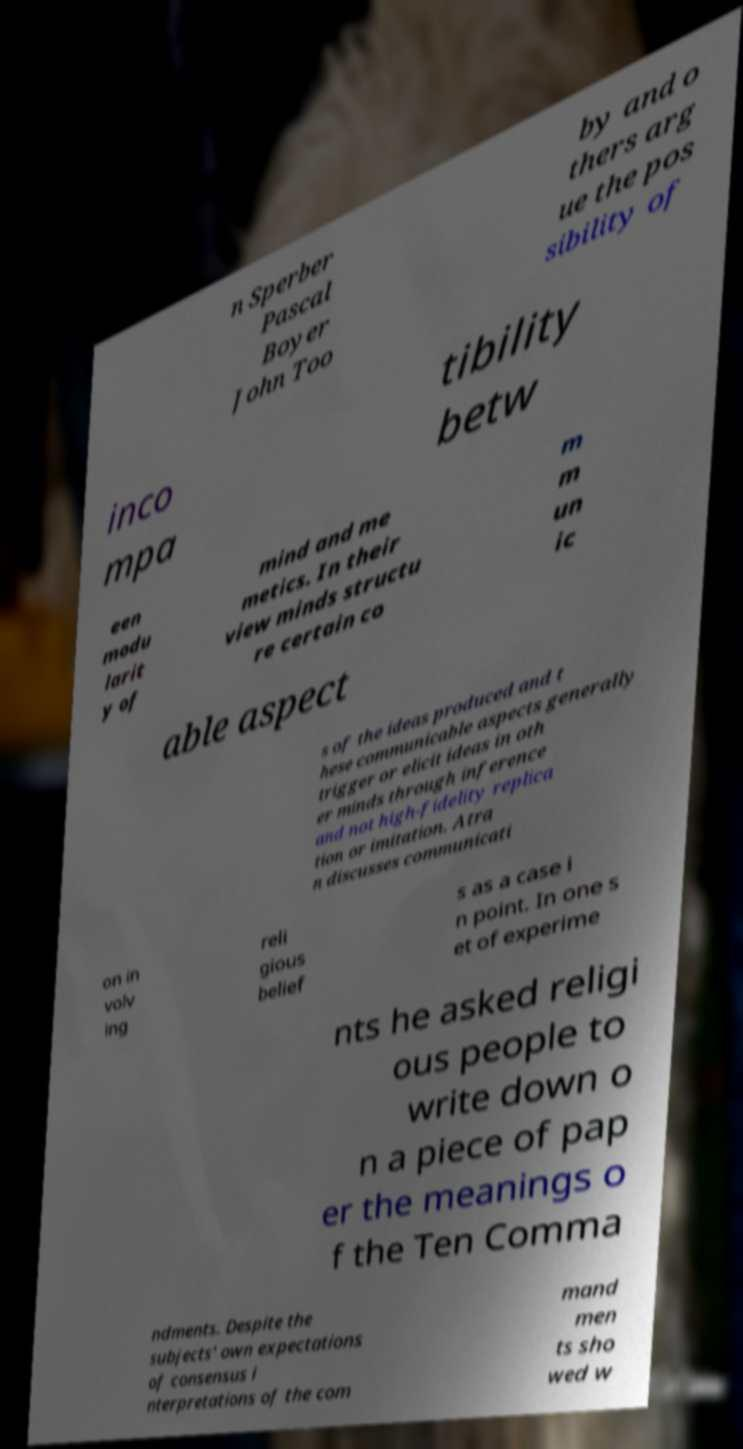What messages or text are displayed in this image? I need them in a readable, typed format. n Sperber Pascal Boyer John Too by and o thers arg ue the pos sibility of inco mpa tibility betw een modu larit y of mind and me metics. In their view minds structu re certain co m m un ic able aspect s of the ideas produced and t hese communicable aspects generally trigger or elicit ideas in oth er minds through inference and not high-fidelity replica tion or imitation. Atra n discusses communicati on in volv ing reli gious belief s as a case i n point. In one s et of experime nts he asked religi ous people to write down o n a piece of pap er the meanings o f the Ten Comma ndments. Despite the subjects' own expectations of consensus i nterpretations of the com mand men ts sho wed w 